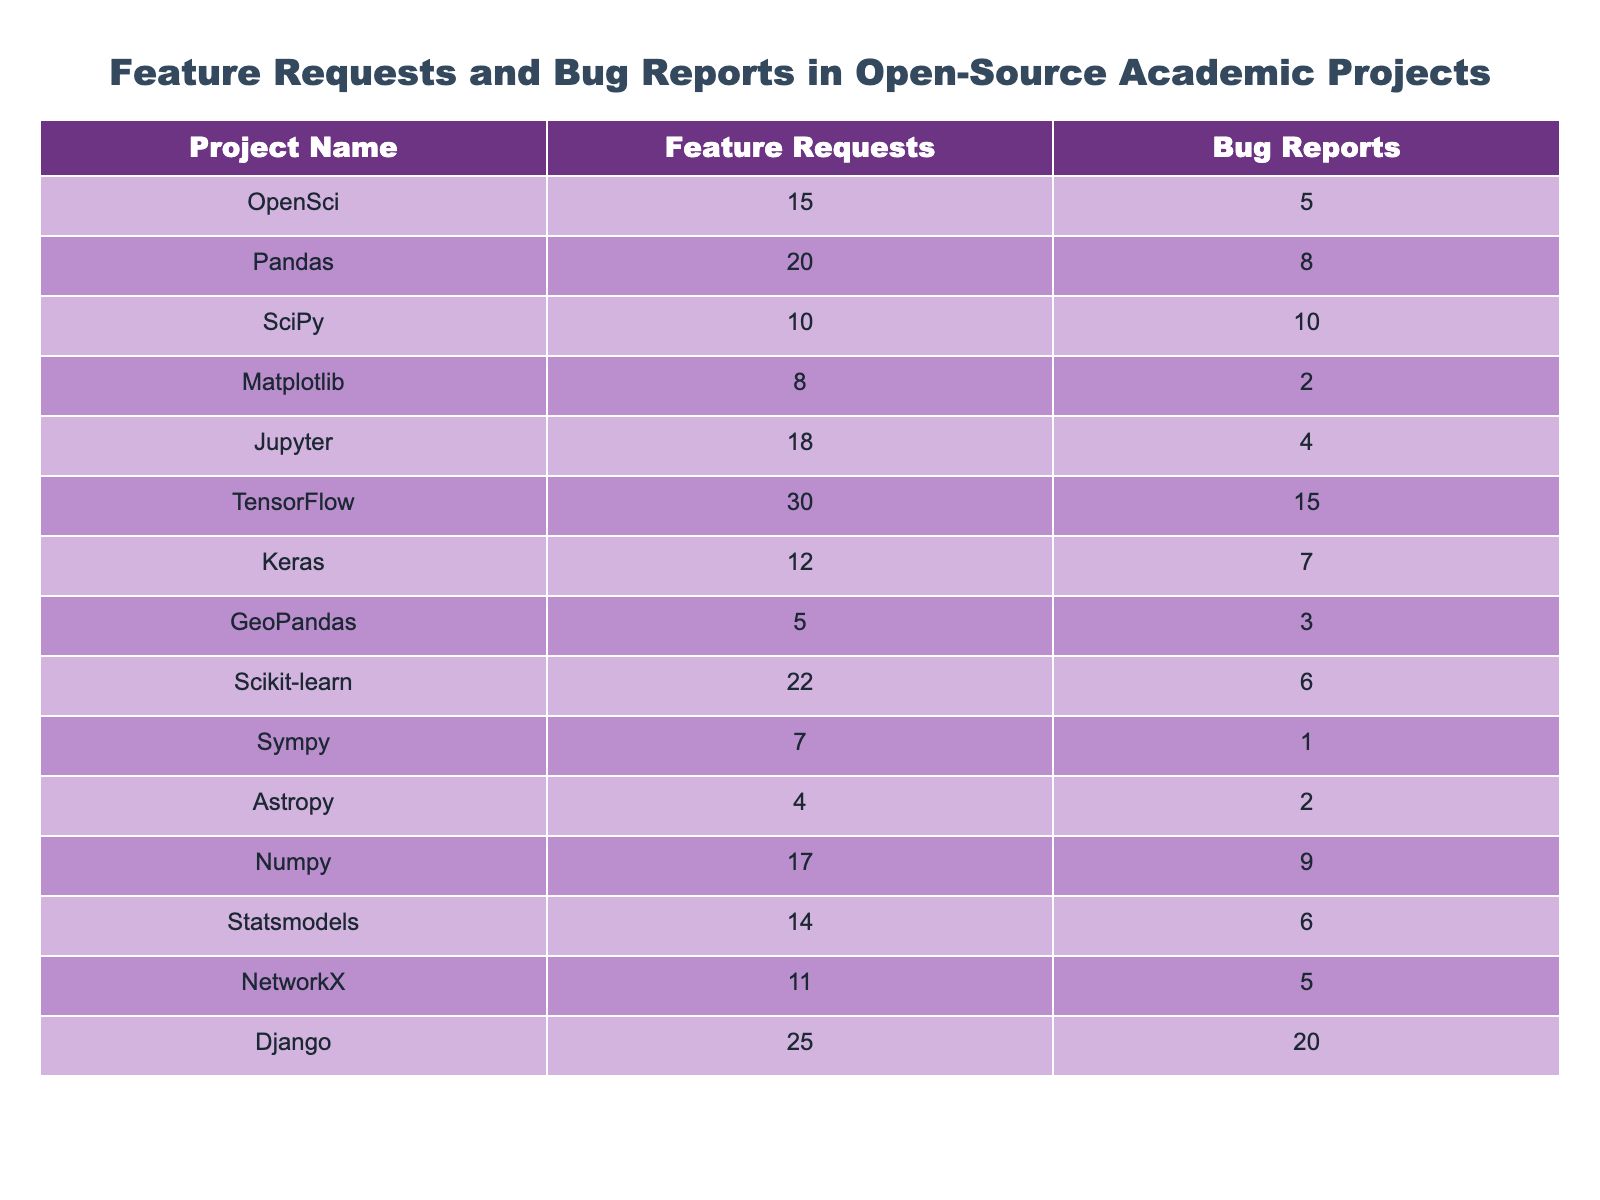What is the total number of feature requests across all projects? To find the total number of feature requests, we sum all the values in the "Feature Requests" column: 15 + 20 + 10 + 8 + 18 + 30 + 12 + 5 + 22 + 7 + 4 + 17 + 14 + 11 + 25 =  20 + 10 + 8 + 18 + 30 + 12 + 5 + 22 + 7 + 4 + 17 + 14 + 11 + 25 =  20 + 10 + 8 + 18 + 30 + 12 + 5 + 22 + 7 + 4 + 17 + 14 =  78 + 25 + 20 + 11 + 14 + 11 + = 27 =  174
Answer: 174 Which project has the highest number of bug reports? By looking at the "Bug Reports" column, the highest value is 20, which belongs to the Django project.
Answer: Django How many more feature requests does TensorFlow have compared to SciPy? TensorFlow has 30 feature requests, and SciPy has 10. The difference is 30 - 10 = 20.
Answer: 20 Is the number of bug reports for Keras greater than the number of feature requests for GeoPandas? Keras has 7 bug reports, while GeoPandas has 5 feature requests. Since 7 is greater than 5, the answer is yes.
Answer: Yes What is the average number of feature requests among all projects? To calculate the average, sum all feature requests (174 from the first question) and divide by the number of projects (15): 174 / 15 = 11.6, rounded to one decimal place.
Answer: 11.6 Which project has the least number of feature requests and how many are they? Looking at the "Feature Requests" column, the project with the least requests is GeoPandas with 5 requests.
Answer: GeoPandas, 5 If we combine the bug reports from Pandas and TensorFlow, how many do we get? Pandas has 8 bug reports and TensorFlow has 15. Summing them gives 8 + 15 = 23.
Answer: 23 What is the difference in the number of feature requests between the project with the most and the least feature requests? The project with the most feature requests is TensorFlow with 30, and the least is GeoPandas with 5. The difference is 30 - 5 = 25.
Answer: 25 How many projects have more feature requests than bug reports? By comparing each project's feature requests to its bug reports, we see that projects are open with more requests than reports: OpenSci, Pandas, Jupyter, TensorFlow, Keras, Scikit-learn, Numpy, Statsmodels, and Django. That's 9 projects.
Answer: 9 What percentage of total feature requests does the TensorFlow project represent? TensorFlow has 30 feature requests, and the total is 174. To find the percentage: (30 / 174) * 100 ≈ 17.24%.
Answer: 17.24% 